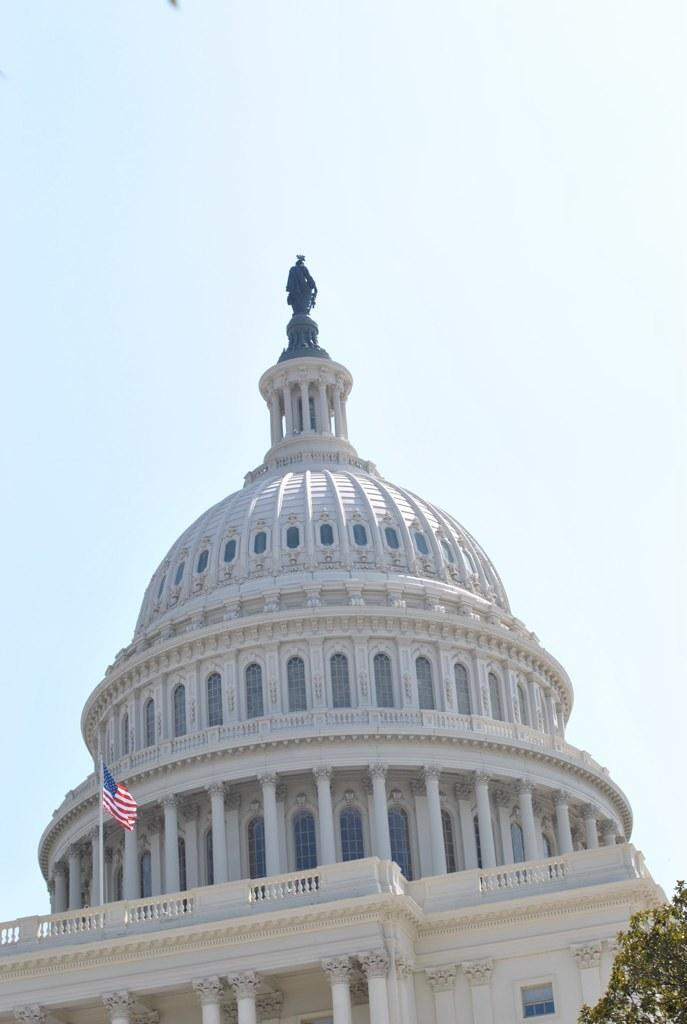What type of structure is present in the image? There is a building in the image. Can you describe the color of the building? The building is white. What else can be seen in the image besides the building? There is a flag and trees in the image. What colors are present on the flag? The flag has blue, red, and white colors. What is the color of the trees in the image? The trees are green. What is visible in the background of the image? The sky is visible in the image. How would you describe the color of the sky in the image? The sky appears white in the image. Can you tell me how many stars are visible on the building in the image? There are no stars visible on the building in the image. What type of cap is the person wearing in the image? There is no person or cap present in the image. 